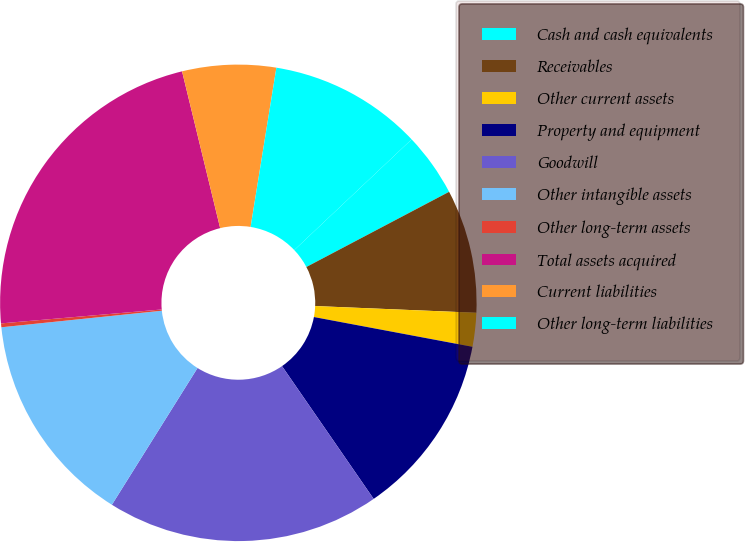Convert chart. <chart><loc_0><loc_0><loc_500><loc_500><pie_chart><fcel>Cash and cash equivalents<fcel>Receivables<fcel>Other current assets<fcel>Property and equipment<fcel>Goodwill<fcel>Other intangible assets<fcel>Other long-term assets<fcel>Total assets acquired<fcel>Current liabilities<fcel>Other long-term liabilities<nl><fcel>4.32%<fcel>8.38%<fcel>2.29%<fcel>12.43%<fcel>18.52%<fcel>14.46%<fcel>0.26%<fcel>22.58%<fcel>6.35%<fcel>10.41%<nl></chart> 